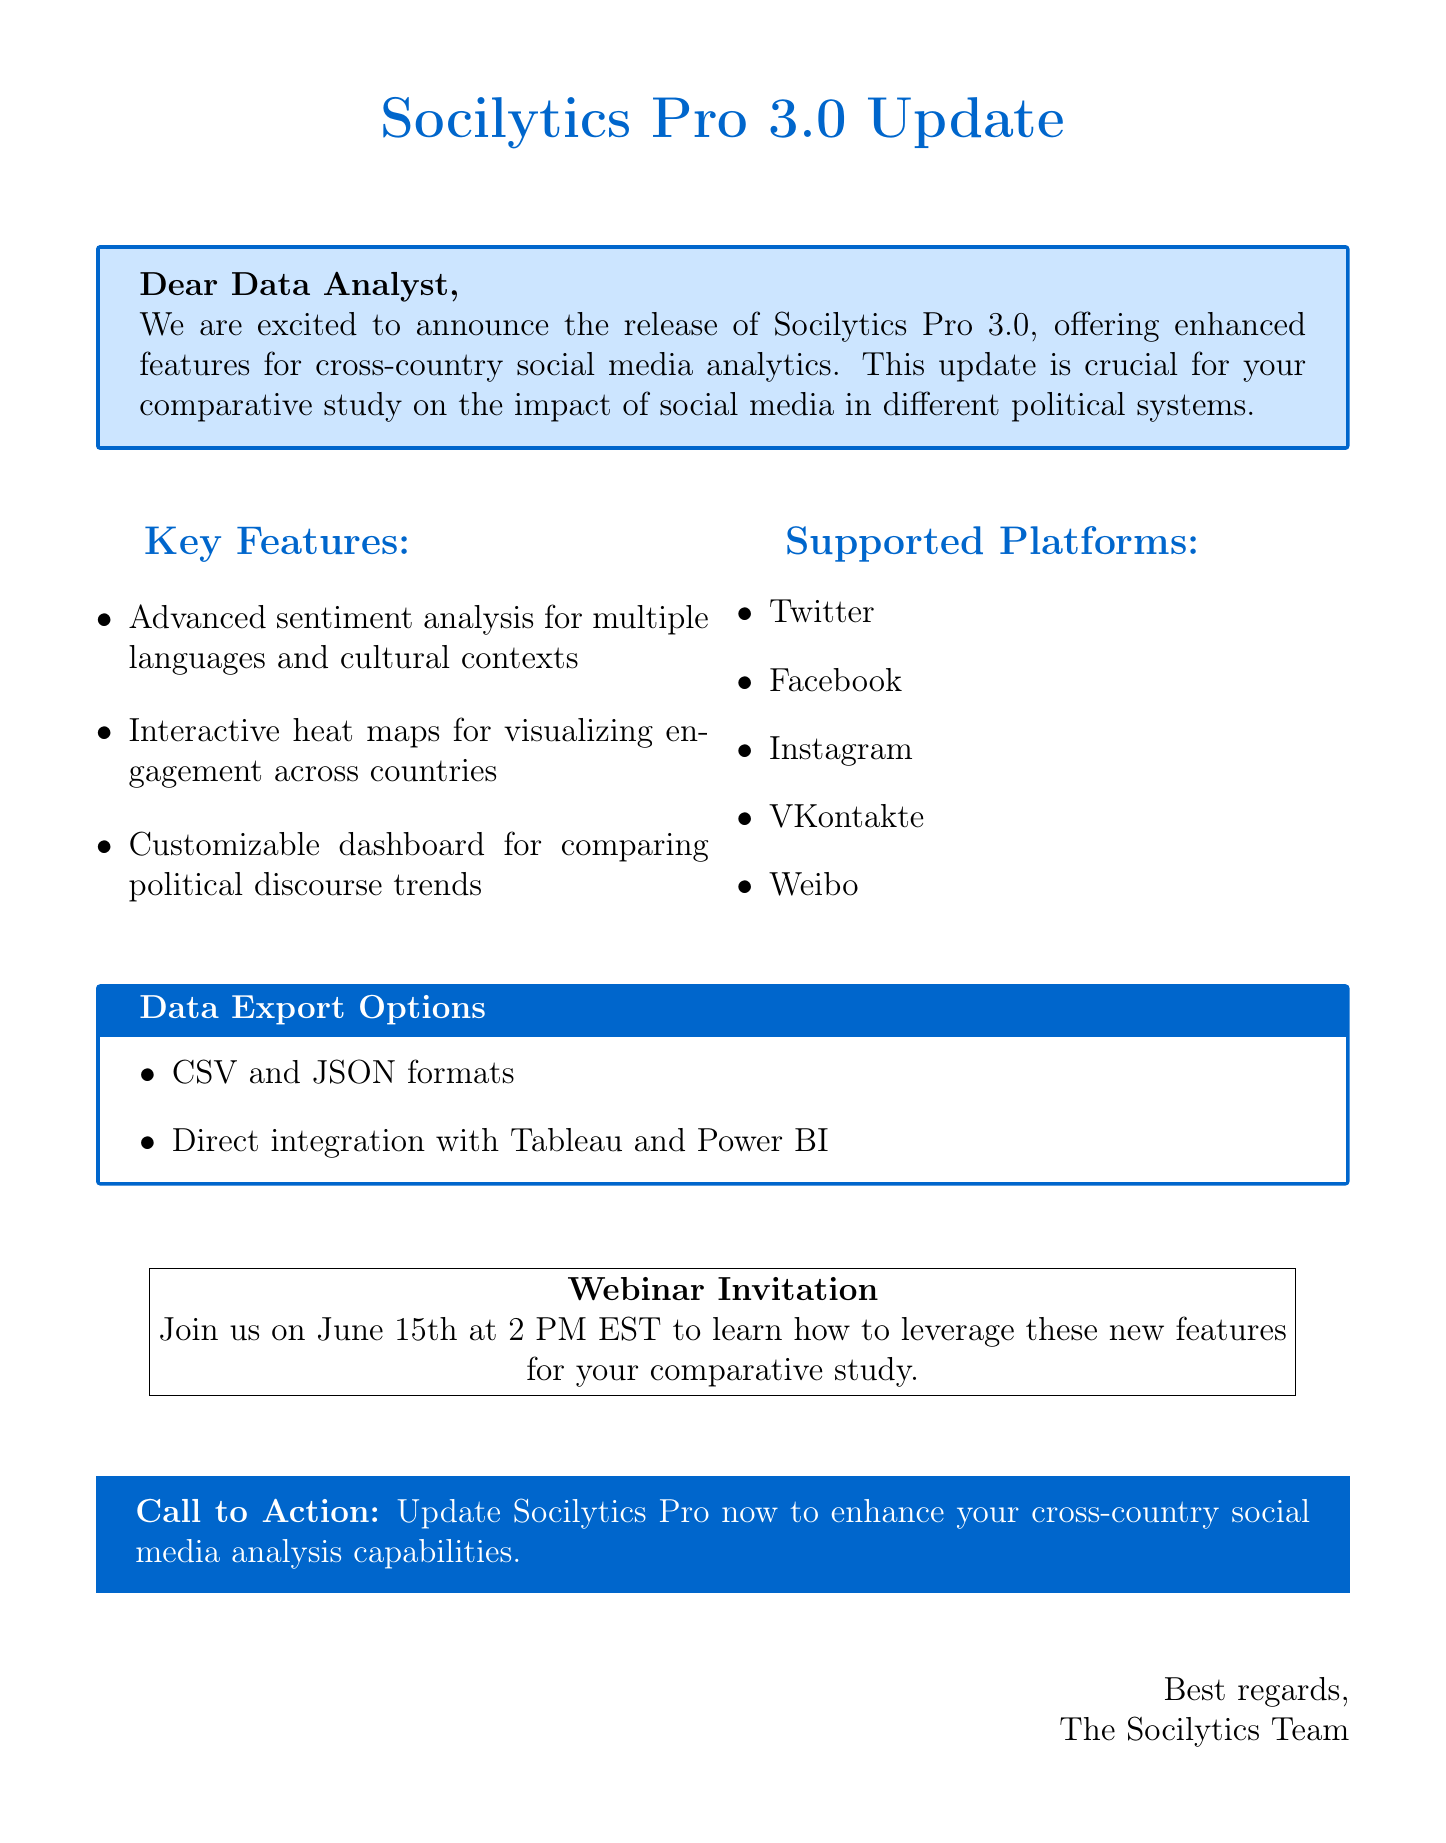What is the version number of the new software? The document specifies the new software version as Socilytics Pro 3.0.
Answer: Socilytics Pro 3.0 What is the main purpose of the update? The document states that the update offers significant improvements for social media analytics across different political systems.
Answer: Enhanced cross-country comparison features When is the webinar scheduled? The document mentions that the webinar is on June 15th at 2 PM EST.
Answer: June 15th, 2 PM EST List one major social media platform supported by the software. The document provides a list of major platforms, including Twitter, Facebook, Instagram, VKontakte, and Weibo.
Answer: Twitter What type of data export options are available? The document lists CSV, JSON, and direct integration with Tableau and Power BI as available formats.
Answer: CSV, JSON, Tableau, Power BI How does the new software facilitate cross-country comparisons? The document explains that it includes interactive heat maps for visualizing social media engagement across different countries.
Answer: Interactive heat maps What kind of analysis features does the new version include? The document mentions advanced sentiment analysis algorithms tailored for multiple languages and cultural contexts.
Answer: Advanced sentiment analysis algorithms What is the call to action mentioned in the email? The document includes a call to action to update Socilytics Pro for enhanced analysis capabilities.
Answer: Update Socilytics Pro now 